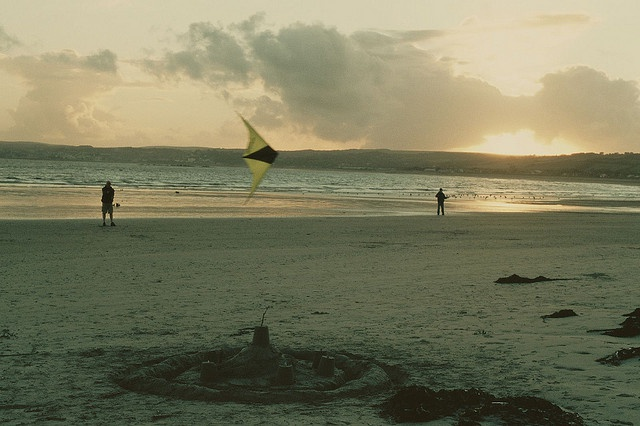Describe the objects in this image and their specific colors. I can see kite in tan, black, and olive tones, people in tan, black, gray, and darkgreen tones, and people in tan, black, gray, and darkgreen tones in this image. 